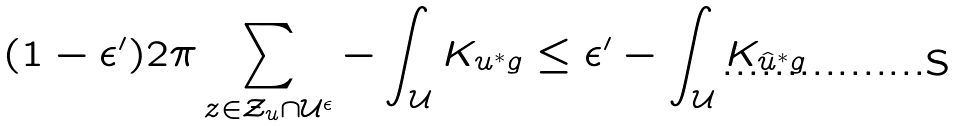<formula> <loc_0><loc_0><loc_500><loc_500>( 1 - \epsilon ^ { \prime } ) 2 \pi \sum _ { z \in \mathcal { Z } _ { u } \cap \mathcal { U } ^ { \epsilon } } - \int _ { \mathcal { U } } K _ { u ^ { * } g } \leq \epsilon ^ { \prime } - \int _ { \mathcal { U } } K _ { \hat { u } ^ { * } g }</formula> 